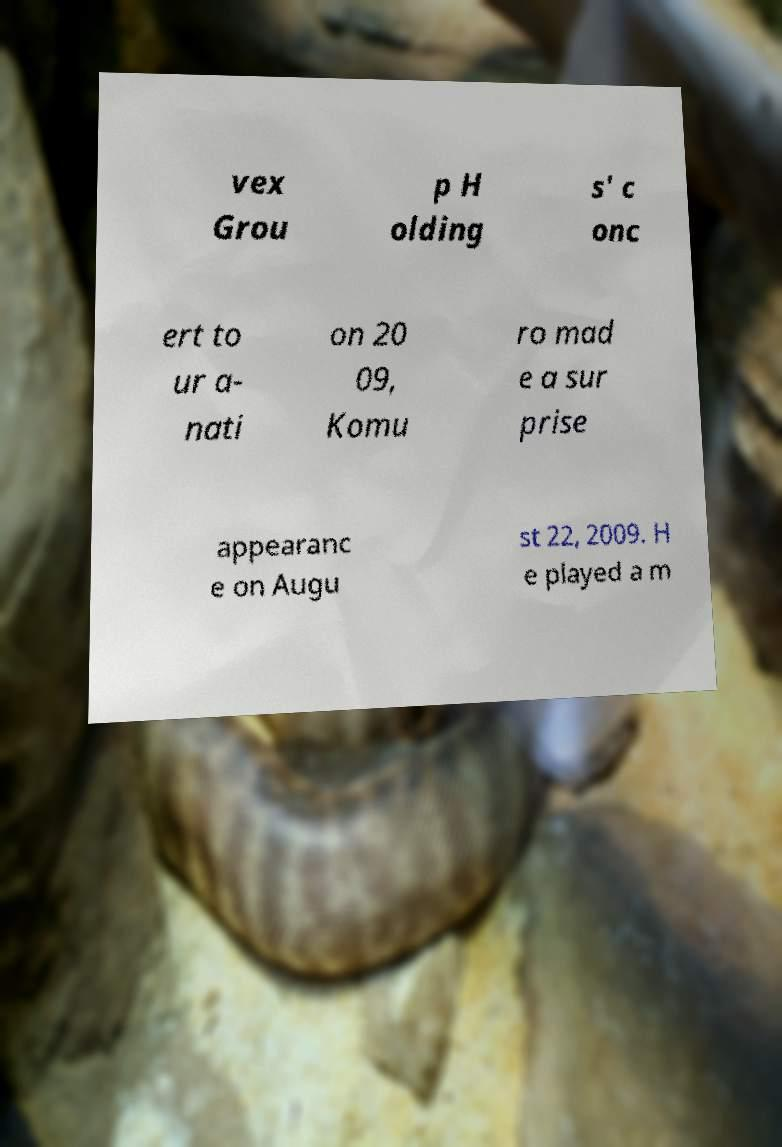For documentation purposes, I need the text within this image transcribed. Could you provide that? vex Grou p H olding s' c onc ert to ur a- nati on 20 09, Komu ro mad e a sur prise appearanc e on Augu st 22, 2009. H e played a m 